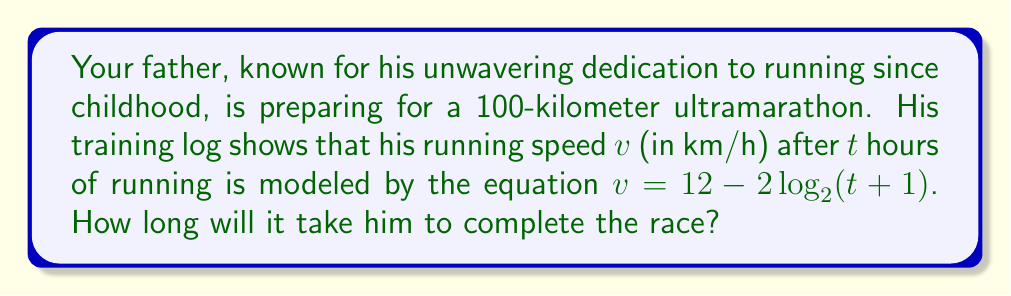Could you help me with this problem? Let's approach this step-by-step:

1) The total distance $d$ covered in time $t$ is the integral of velocity over time:

   $$d = \int_0^t v \, dt = \int_0^t (12 - 2\log_2(t+1)) \, dt$$

2) Integrating this equation:
   
   $$d = 12t - 2t\log_2(t+1) + 2t - 2(\ln 2)^{-1}(t+1)\ln(t+1) + C$$

3) We know that at $t=0$, $d=0$, so $C = 2(\ln 2)^{-1}$

4) Therefore, the equation for distance is:

   $$d = 12t - 2t\log_2(t+1) + 2t - 2(\ln 2)^{-1}(t+1)\ln(t+1) + 2(\ln 2)^{-1}$$

5) We want to find $t$ when $d = 100$. This gives us the equation:

   $$100 = 12t - 2t\log_2(t+1) + 2t - 2(\ln 2)^{-1}(t+1)\ln(t+1) + 2(\ln 2)^{-1}$$

6) This equation cannot be solved algebraically. We need to use numerical methods to solve it.

7) Using a numerical solver (like Newton's method), we find that $t \approx 10.76$ hours.
Answer: $10.76$ hours 